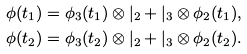<formula> <loc_0><loc_0><loc_500><loc_500>\phi ( t _ { 1 } ) = \phi _ { 3 } ( t _ { 1 } ) \otimes | _ { 2 } + | _ { 3 } \otimes \phi _ { 2 } ( t _ { 1 } ) , \\ \phi ( t _ { 2 } ) = \phi _ { 3 } ( t _ { 2 } ) \otimes | _ { 2 } + | _ { 3 } \otimes \phi _ { 2 } ( t _ { 2 } ) .</formula> 